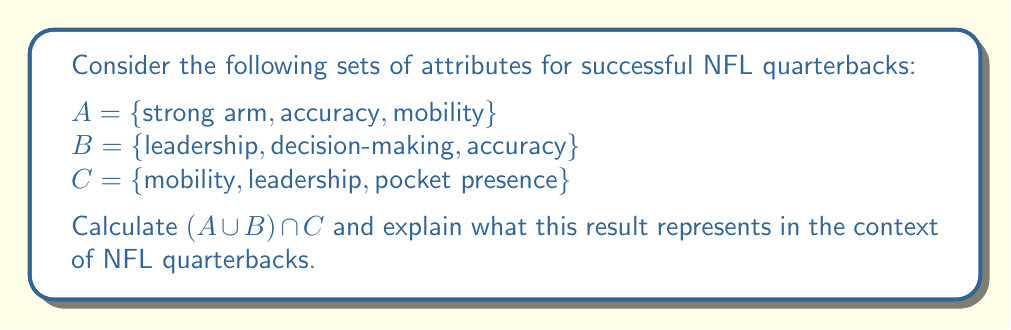Provide a solution to this math problem. To solve this problem, we'll follow these steps:

1) First, let's find $A \cup B$:
   $A \cup B = \{strong arm, accuracy, mobility, leadership, decision-making\}$

2) Now, we need to find the intersection of this result with C:
   $(A \cup B) \cap C = \{mobility, leadership\}$

3) Interpretation:
   The resulting set represents the attributes that are common to both the combined set of A and B, and set C. In other words, these are the attributes that are present in C and also in either A or B (or both).

In the context of NFL quarterbacks, this result suggests that mobility and leadership are key attributes that are valued across different perspectives of what makes a successful quarterback. Mobility is important for evading pressure and extending plays, while leadership is crucial for guiding the team and maintaining composure under pressure.

This type of analysis can be valuable for aspiring NFL players, as it highlights the attributes that are consistently valued across different evaluations of quarterback success. By focusing on developing these attributes, a player can increase their chances of success at the highest level of the sport.
Answer: $(A \cup B) \cap C = \{mobility, leadership\}$ 